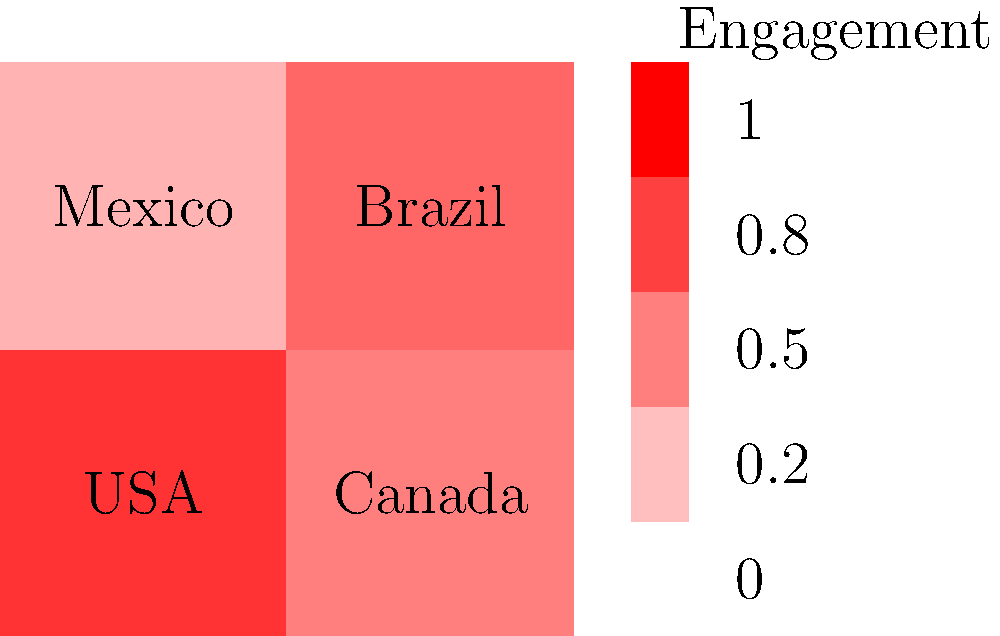Based on the heat map showing religious content engagement across different countries, which country has the highest level of engagement, and what is the approximate engagement value? To answer this question, we need to analyze the heat map and interpret the color intensity for each country:

1. Observe the color legend on the right side of the map. The darker red colors indicate higher engagement levels, while lighter colors represent lower engagement.

2. Compare the colors of each country:
   - USA: Dark red
   - Canada: Medium red
   - Mexico: Light red
   - Brazil: Medium-dark red

3. The darkest red color corresponds to the USA, indicating the highest engagement level.

4. Referring to the legend, we can see that the darkest red corresponds to an engagement value of approximately $0.8$.

5. Therefore, the USA has the highest level of engagement with an approximate value of $0.8$.
Answer: USA, $0.8$ 